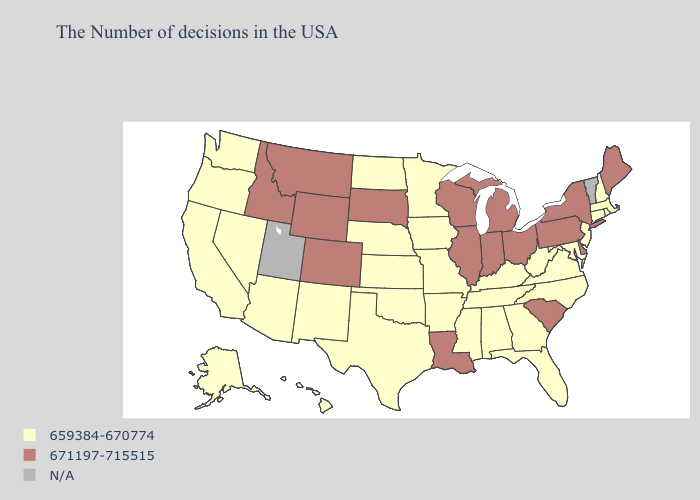Among the states that border Nevada , does Idaho have the lowest value?
Quick response, please. No. What is the value of Indiana?
Answer briefly. 671197-715515. What is the value of Alaska?
Give a very brief answer. 659384-670774. Name the states that have a value in the range 659384-670774?
Quick response, please. Massachusetts, Rhode Island, New Hampshire, Connecticut, New Jersey, Maryland, Virginia, North Carolina, West Virginia, Florida, Georgia, Kentucky, Alabama, Tennessee, Mississippi, Missouri, Arkansas, Minnesota, Iowa, Kansas, Nebraska, Oklahoma, Texas, North Dakota, New Mexico, Arizona, Nevada, California, Washington, Oregon, Alaska, Hawaii. What is the lowest value in the USA?
Write a very short answer. 659384-670774. What is the value of New Mexico?
Give a very brief answer. 659384-670774. What is the value of Wyoming?
Answer briefly. 671197-715515. What is the highest value in the USA?
Answer briefly. 671197-715515. Among the states that border Ohio , which have the highest value?
Give a very brief answer. Pennsylvania, Michigan, Indiana. Which states have the highest value in the USA?
Write a very short answer. Maine, New York, Delaware, Pennsylvania, South Carolina, Ohio, Michigan, Indiana, Wisconsin, Illinois, Louisiana, South Dakota, Wyoming, Colorado, Montana, Idaho. What is the value of Oklahoma?
Give a very brief answer. 659384-670774. What is the lowest value in the MidWest?
Be succinct. 659384-670774. Does the map have missing data?
Short answer required. Yes. 